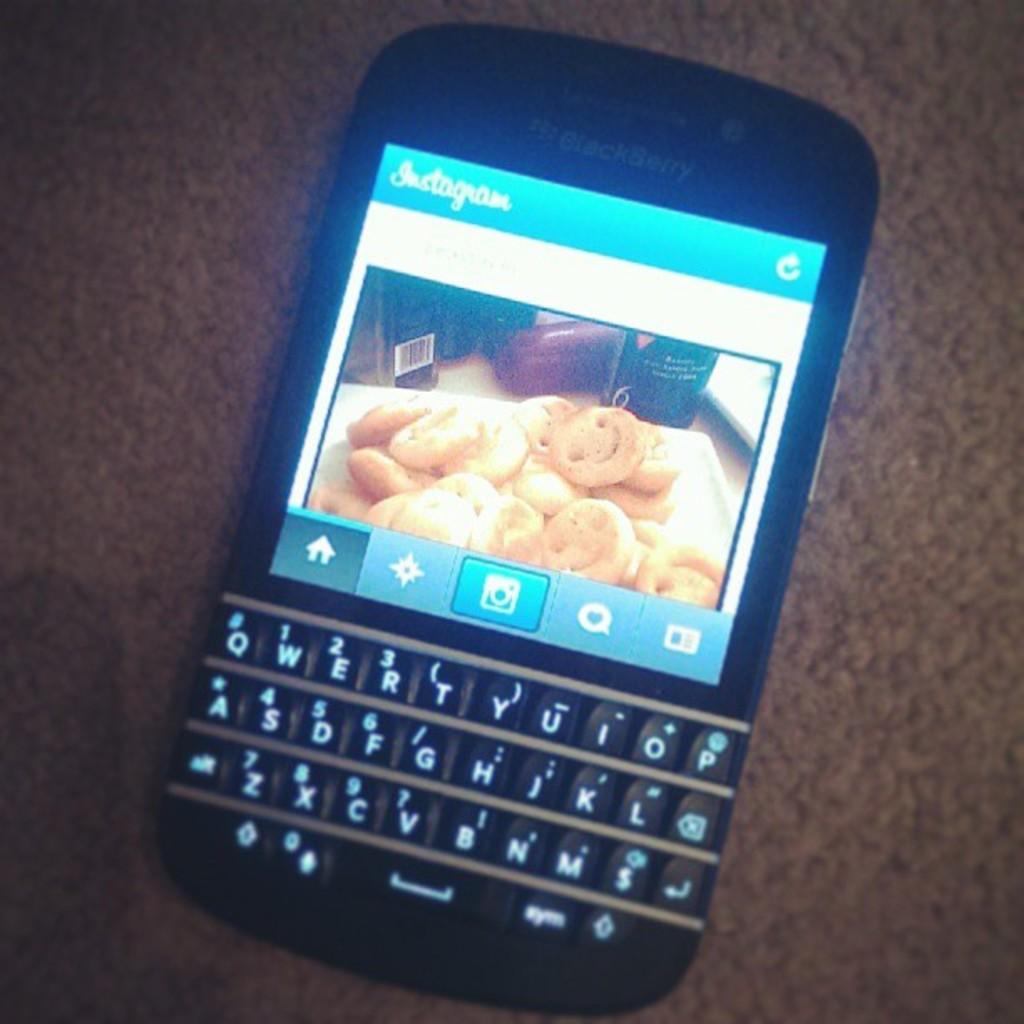What app is open on the phone?
Provide a succinct answer. Instagram. 